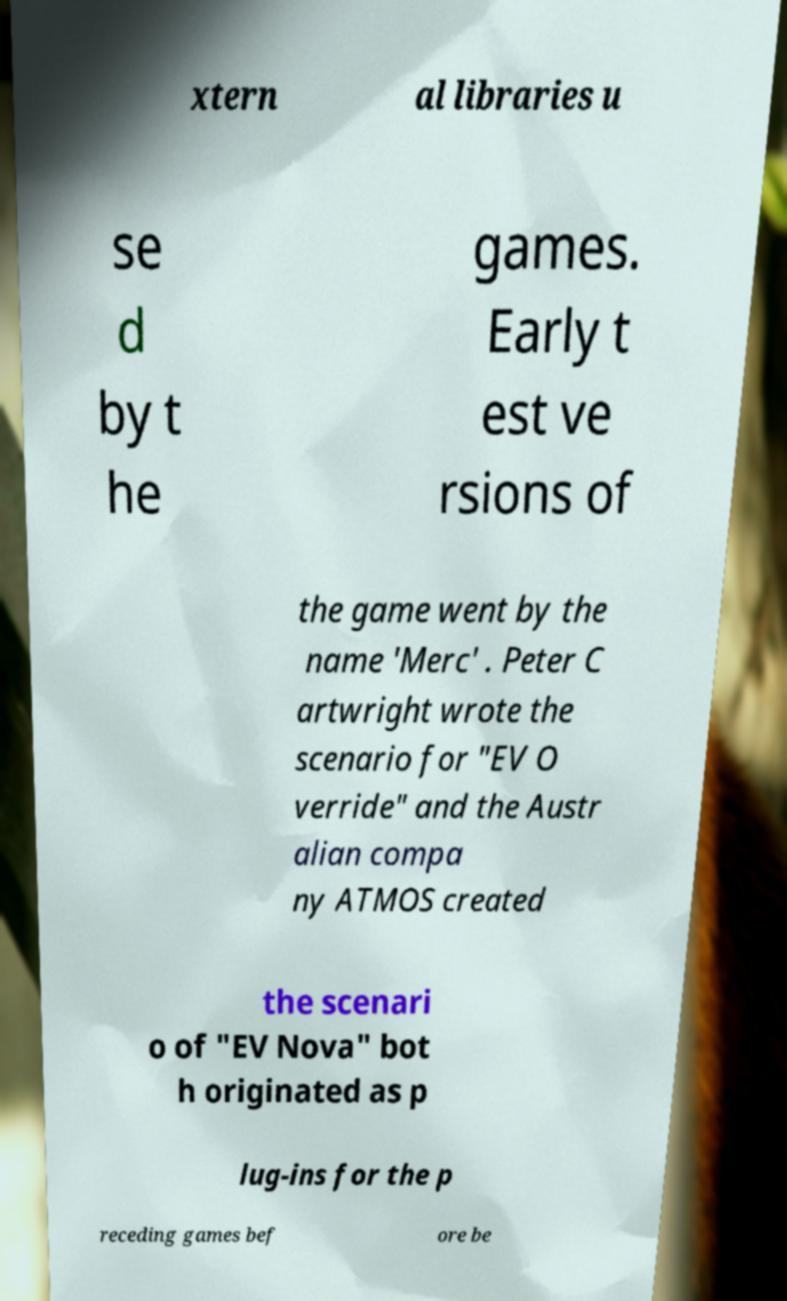Please identify and transcribe the text found in this image. xtern al libraries u se d by t he games. Early t est ve rsions of the game went by the name 'Merc' . Peter C artwright wrote the scenario for "EV O verride" and the Austr alian compa ny ATMOS created the scenari o of "EV Nova" bot h originated as p lug-ins for the p receding games bef ore be 